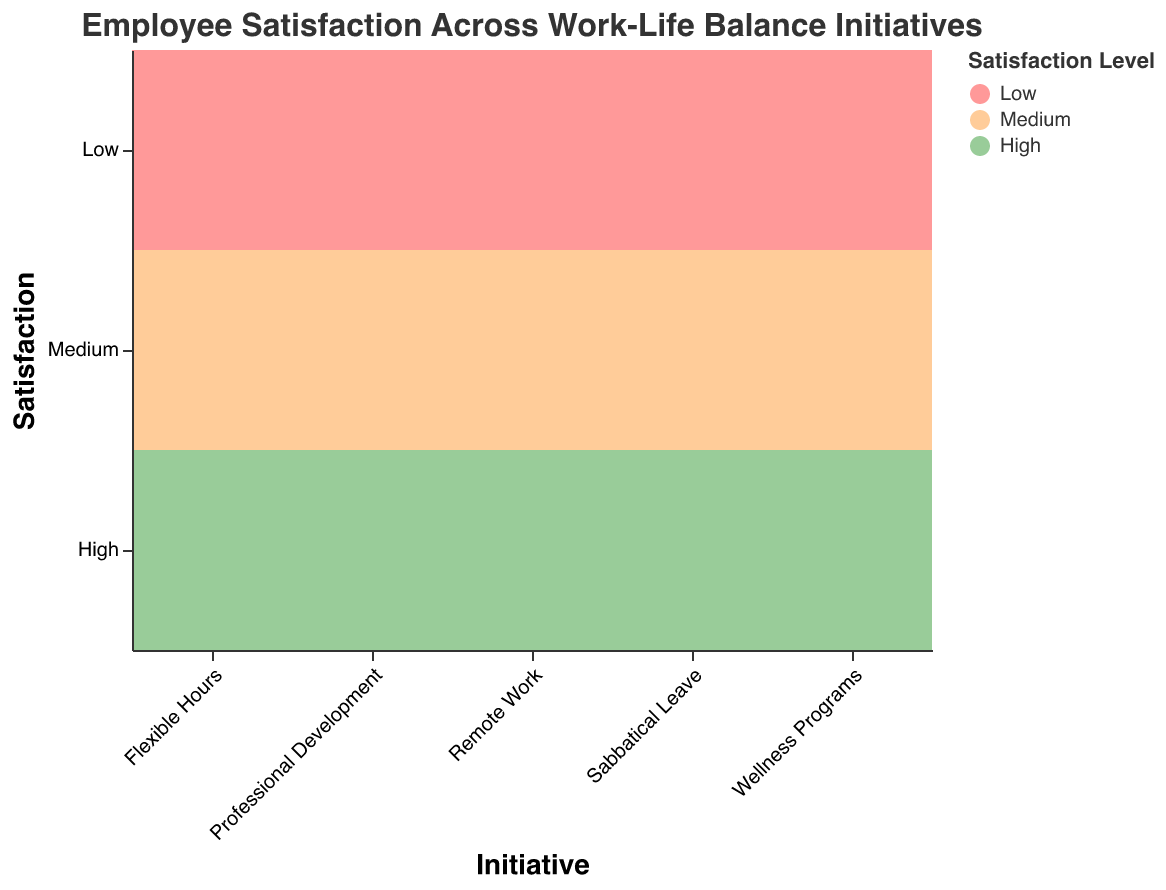What is the title of the figure? The title is located at the top of the plot and states the main subject of the visualization.
Answer: Employee Satisfaction Across Work-Life Balance Initiatives Which work-life balance initiative has the highest number of employees reporting high satisfaction? To find the answer, look for the largest "High" satisfaction block and note the corresponding initiative. Flexible Hours has the largest "High" satisfaction block with 320 employees reported.
Answer: Flexible Hours How many employees report medium satisfaction for Sabbatical Leave? Identify the "Medium" satisfaction block for Sabbatical Leave and read the corresponding number in the block.
Answer: 200 What is the sum of employees reporting low satisfaction across all initiatives? Sum the values associated with "Low" satisfaction for each initiative: 50 + 60 + 90 + 80 + 150 = 430.
Answer: 430 Which initiative has the smallest difference between high and low satisfaction levels, in terms of the number of employees? Calculate the difference between the number of employees in the "High" and "Low" satisfaction categories for each initiative; find the smallest difference. For Sabbatical Leave, the difference is 150 - 150 = 0.
Answer: Sabbatical Leave Compare the number of employees with high satisfaction levels between Remote Work and Professional Development. Which one has more? Compare the "High" blocks for Remote Work and Professional Development: Remote Work has 280 employees, and Professional Development has 250.
Answer: Remote Work For which initiative is the proportion of employees with medium satisfaction the greatest? Calculate the proportion of employees with "Medium" satisfaction for each initiative and determine which has the highest proportion: Flexible Hours has 180 / (320+180+50) = 0.31, Remote Work has 160 / (280+160+60) = 0.31, Wellness Programs has 190 / (220+190+90) = 0.35, Professional Development has 170 / (250+170+80) = 0.32, Sabbatical Leave has 200/ (150+200+150) = 0.44. Sabbatical Leave has the highest proportion at 44%.
Answer: Sabbatical Leave What is the total number of employees represented in the plot? Sum all employee counts across all satisfaction levels and initiatives: 320+180+50+280+160+60+220+190+90+250+170+80+150+200+150 = 2,850 employees.
Answer: 2,850 Which satisfaction level is most commonly reported for Wellness Programs? Identify the block with the highest number of employees for Wellness Programs. The "Medium" satisfaction level has 190 employees.
Answer: Medium 